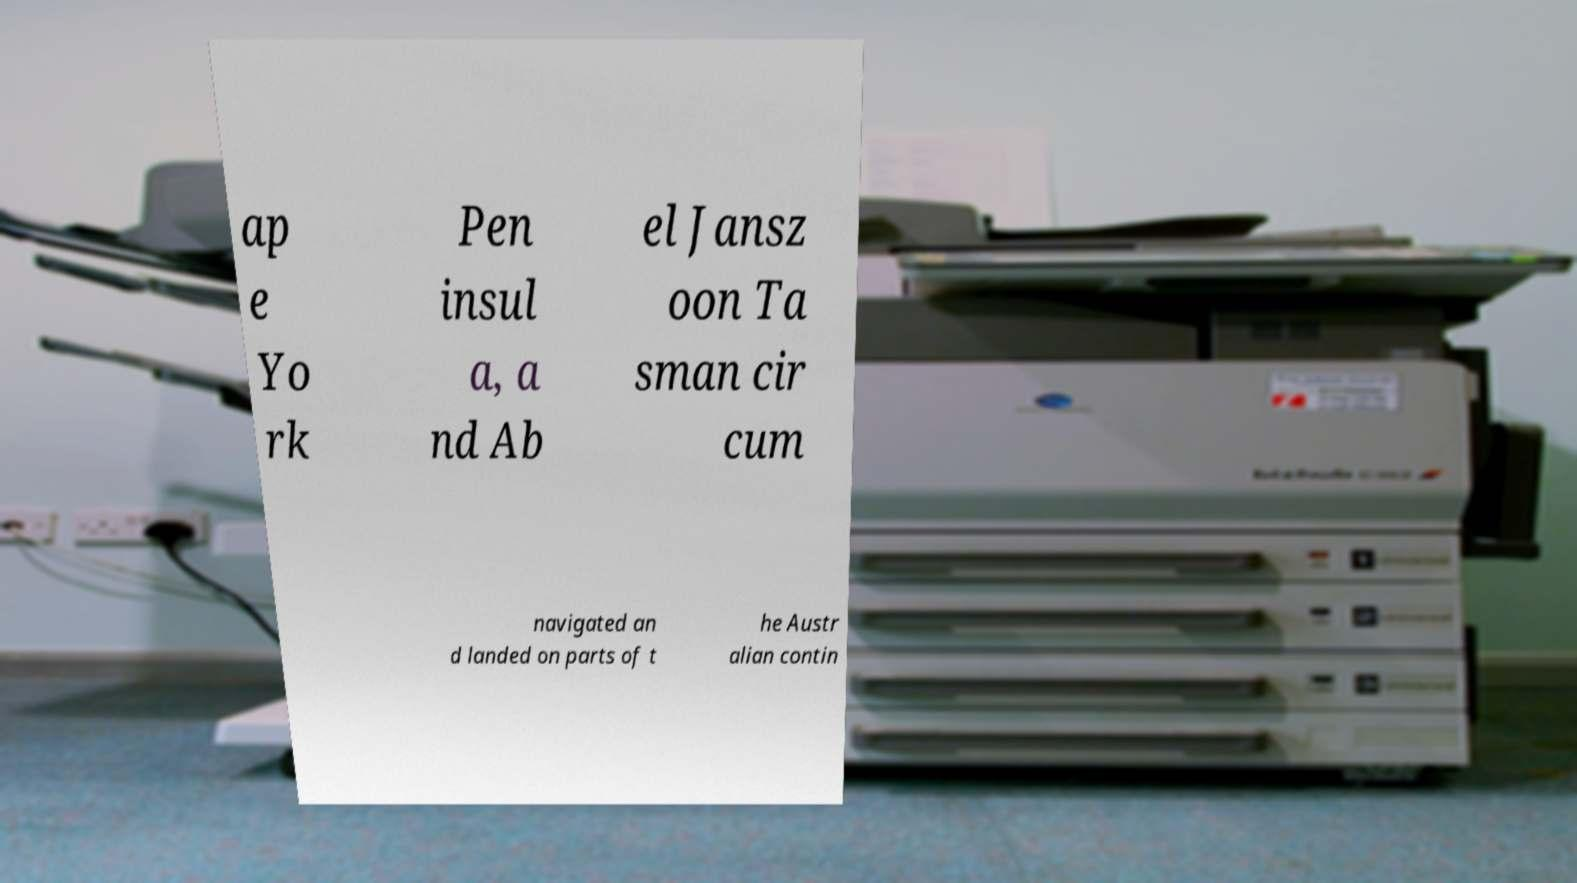For documentation purposes, I need the text within this image transcribed. Could you provide that? ap e Yo rk Pen insul a, a nd Ab el Jansz oon Ta sman cir cum navigated an d landed on parts of t he Austr alian contin 